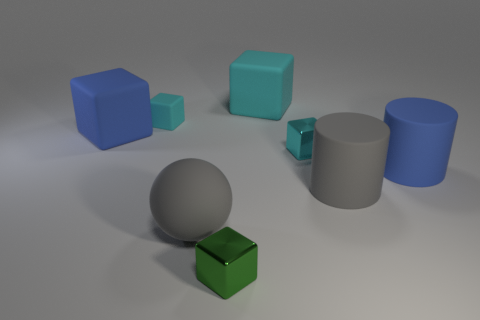What number of tiny things are cyan objects or brown matte objects?
Provide a short and direct response. 2. Are there any green metallic objects of the same shape as the tiny cyan matte thing?
Ensure brevity in your answer.  Yes. Do the cyan metal object and the green thing have the same shape?
Ensure brevity in your answer.  Yes. What color is the rubber object behind the tiny object to the left of the large rubber sphere?
Provide a succinct answer. Cyan. The rubber block that is the same size as the cyan shiny block is what color?
Provide a succinct answer. Cyan. What number of metal objects are tiny spheres or cylinders?
Provide a short and direct response. 0. There is a big blue thing that is on the left side of the large cyan thing; how many big spheres are left of it?
Provide a short and direct response. 0. There is a cylinder that is the same color as the large ball; what is its size?
Give a very brief answer. Large. How many objects are either small shiny objects or big blocks that are to the left of the large gray matte ball?
Provide a succinct answer. 3. Are there any balls made of the same material as the green object?
Make the answer very short. No. 